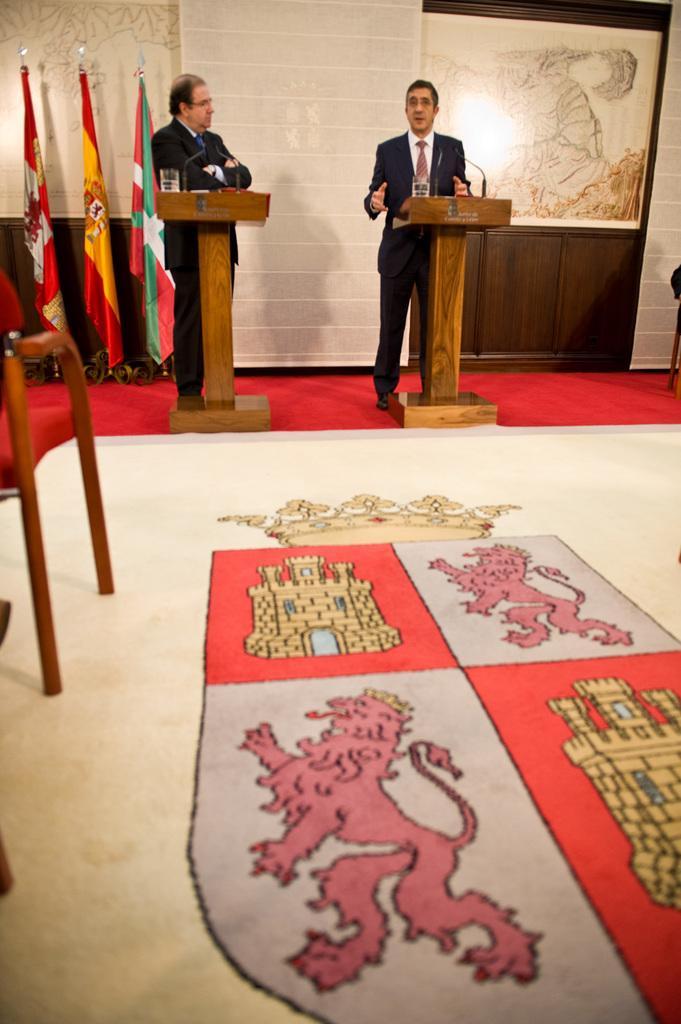Can you describe this image briefly? There are two persons standing, and wearing suits. One of them is speaking and other one is listening to him. in front of them there are stands which are made up with wood. In the background, there is a wall, photo frame, flags, carpet, and some other materials. In front of them, there are chairs, flag, and some other materials. 